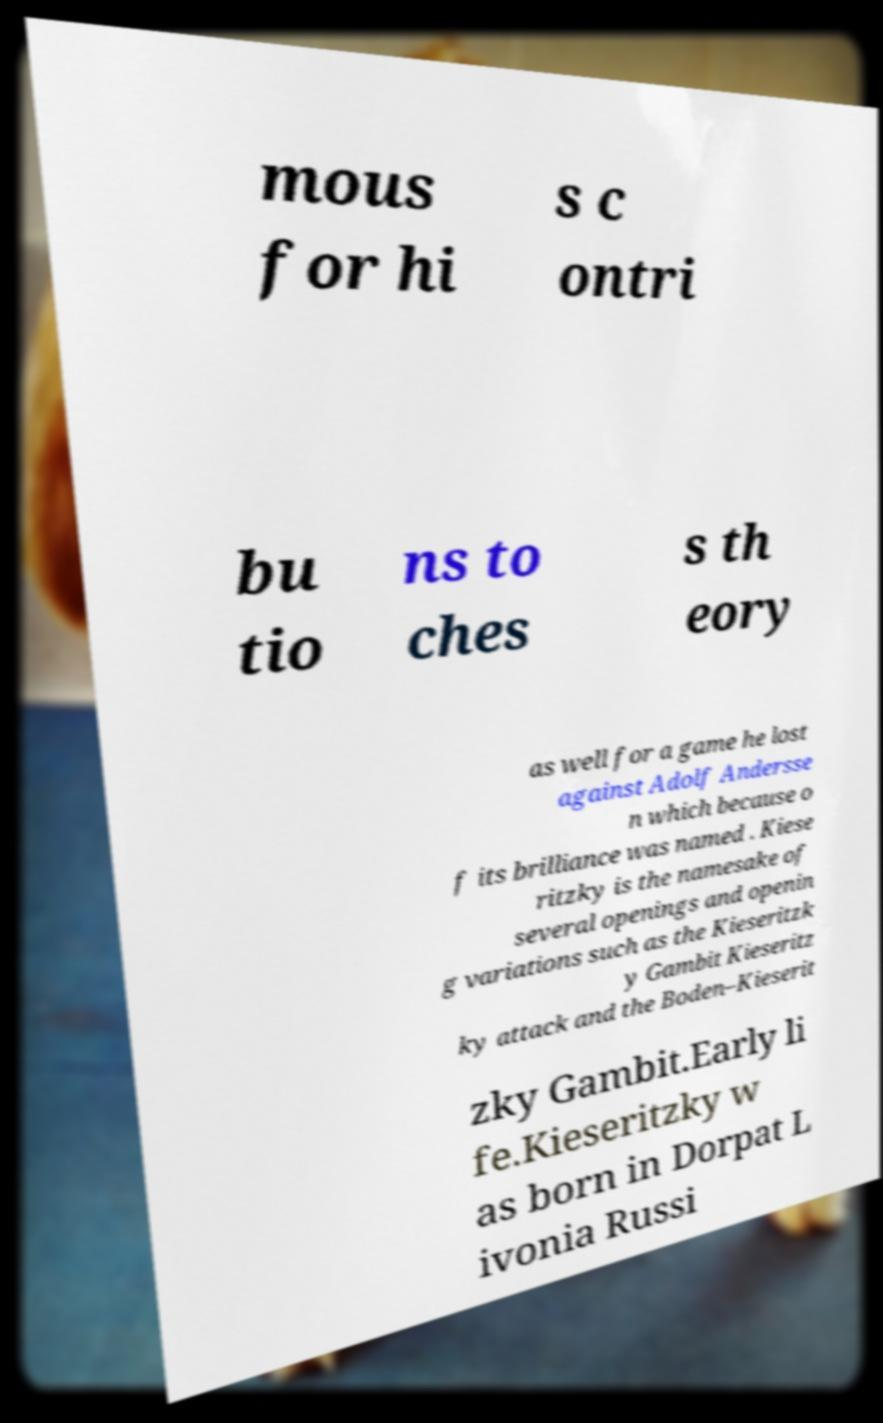For documentation purposes, I need the text within this image transcribed. Could you provide that? mous for hi s c ontri bu tio ns to ches s th eory as well for a game he lost against Adolf Andersse n which because o f its brilliance was named . Kiese ritzky is the namesake of several openings and openin g variations such as the Kieseritzk y Gambit Kieseritz ky attack and the Boden–Kieserit zky Gambit.Early li fe.Kieseritzky w as born in Dorpat L ivonia Russi 